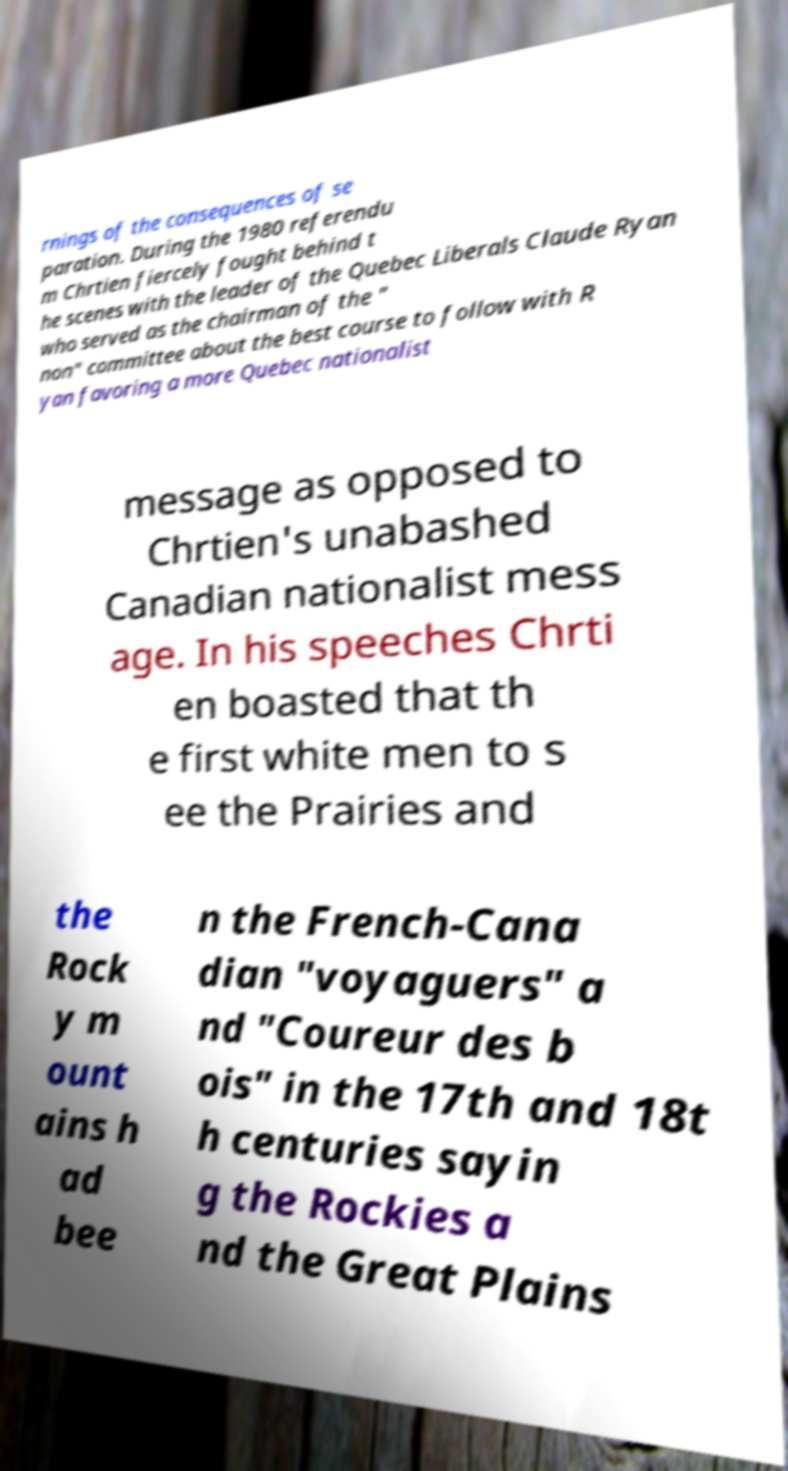Can you read and provide the text displayed in the image?This photo seems to have some interesting text. Can you extract and type it out for me? rnings of the consequences of se paration. During the 1980 referendu m Chrtien fiercely fought behind t he scenes with the leader of the Quebec Liberals Claude Ryan who served as the chairman of the " non" committee about the best course to follow with R yan favoring a more Quebec nationalist message as opposed to Chrtien's unabashed Canadian nationalist mess age. In his speeches Chrti en boasted that th e first white men to s ee the Prairies and the Rock y m ount ains h ad bee n the French-Cana dian "voyaguers" a nd "Coureur des b ois" in the 17th and 18t h centuries sayin g the Rockies a nd the Great Plains 